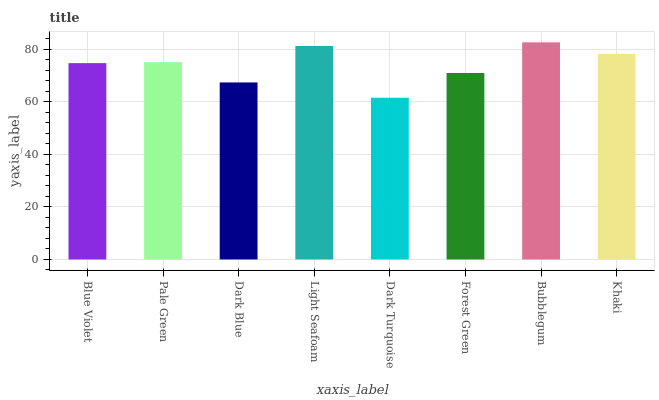Is Dark Turquoise the minimum?
Answer yes or no. Yes. Is Bubblegum the maximum?
Answer yes or no. Yes. Is Pale Green the minimum?
Answer yes or no. No. Is Pale Green the maximum?
Answer yes or no. No. Is Pale Green greater than Blue Violet?
Answer yes or no. Yes. Is Blue Violet less than Pale Green?
Answer yes or no. Yes. Is Blue Violet greater than Pale Green?
Answer yes or no. No. Is Pale Green less than Blue Violet?
Answer yes or no. No. Is Pale Green the high median?
Answer yes or no. Yes. Is Blue Violet the low median?
Answer yes or no. Yes. Is Dark Turquoise the high median?
Answer yes or no. No. Is Khaki the low median?
Answer yes or no. No. 